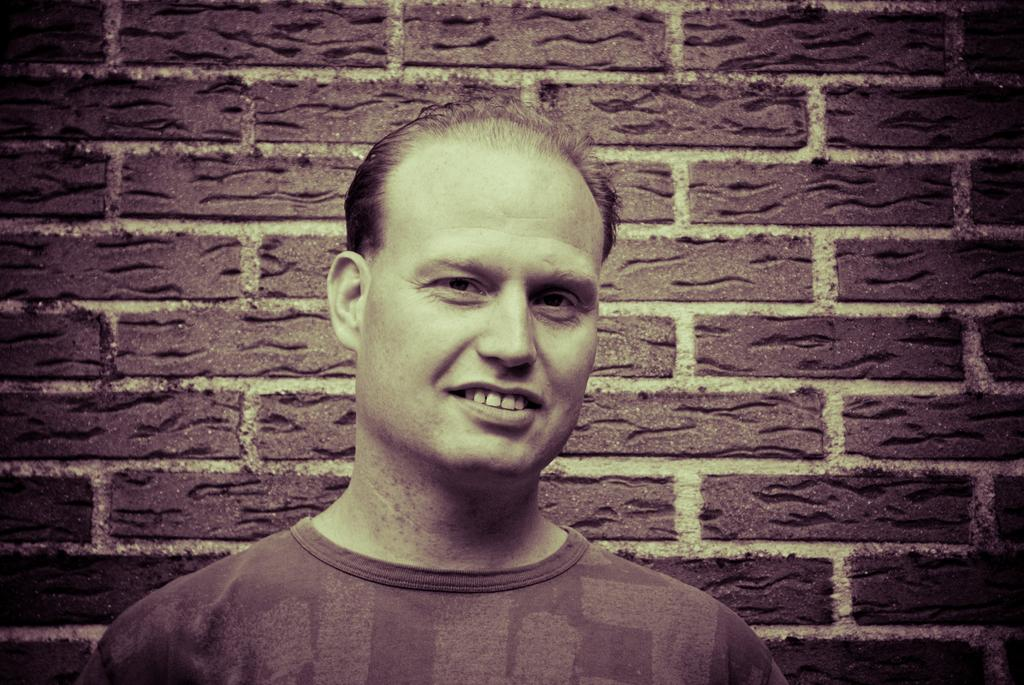What is the main subject in the center of the image? There is a person with a t-shirt in the center of the image. What can be seen in the background of the image? There is a brick wall in the background of the image. What type of bread is being used to decorate the holiday scene in the image? There is no bread or holiday scene present in the image; it features a person with a t-shirt and a brick wall in the background. 